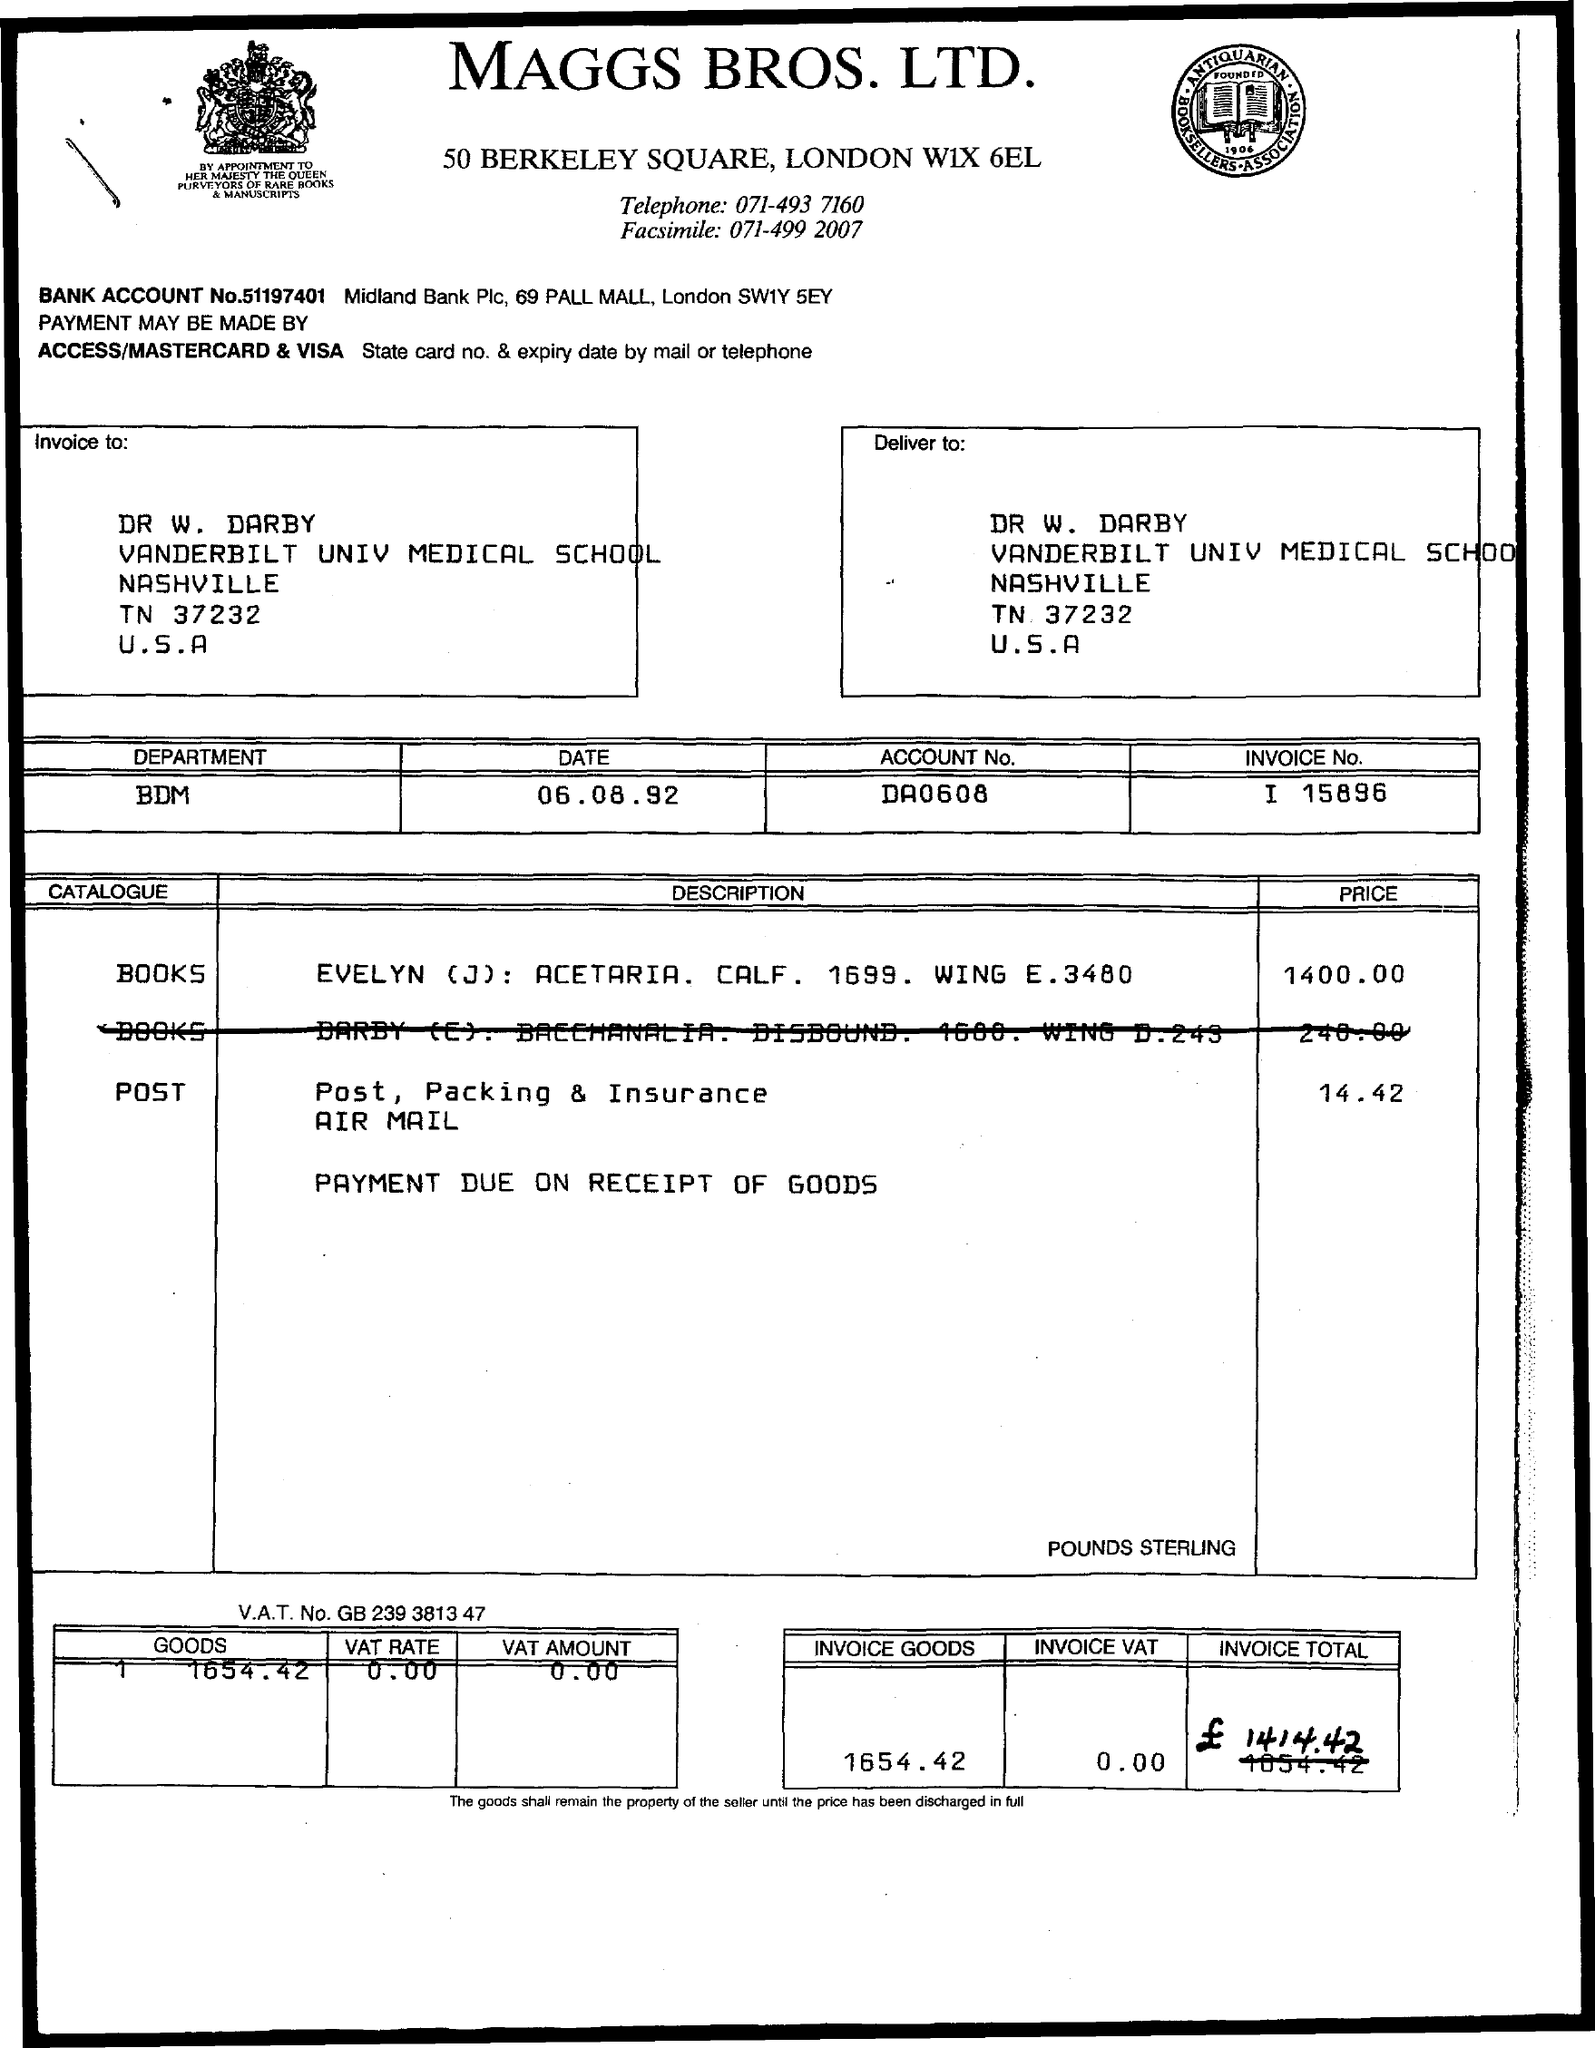Give some essential details in this illustration. What is the VAT rate? It is 0.00%. The VAT amount is 0.00. The price of the post is 14.42. The title of the document is from Maggs Bros, Ltd. The account number is 'da0608..'. 